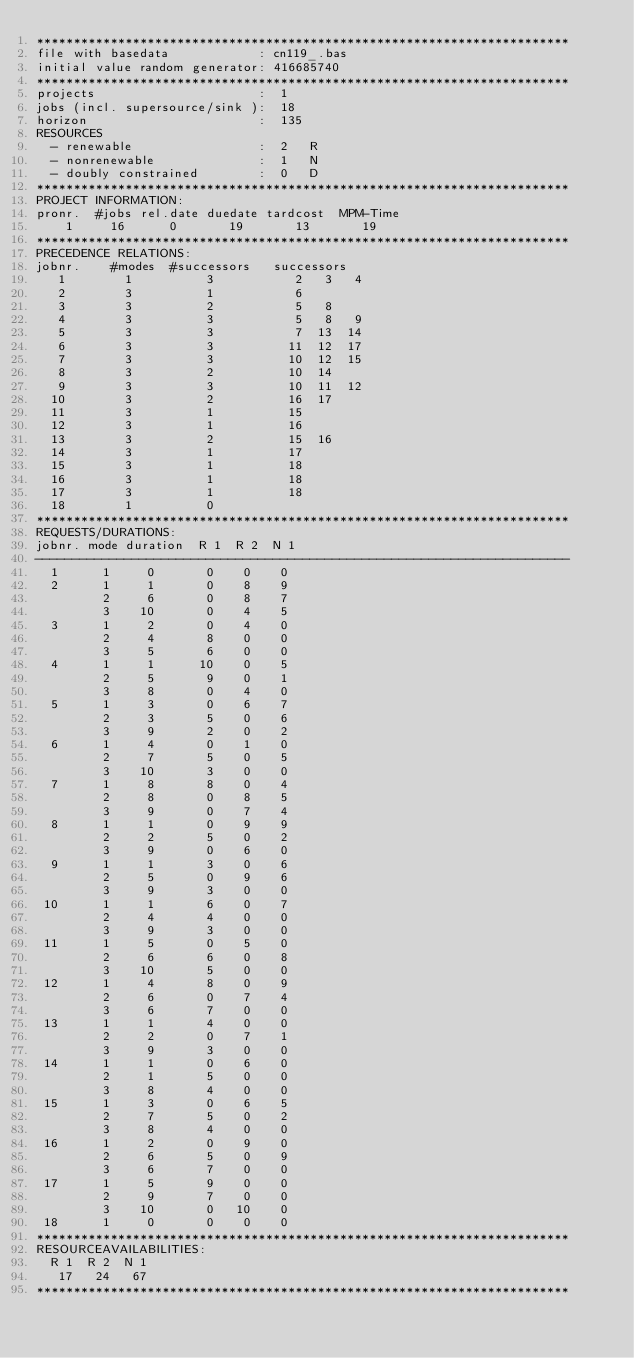Convert code to text. <code><loc_0><loc_0><loc_500><loc_500><_ObjectiveC_>************************************************************************
file with basedata            : cn119_.bas
initial value random generator: 416685740
************************************************************************
projects                      :  1
jobs (incl. supersource/sink ):  18
horizon                       :  135
RESOURCES
  - renewable                 :  2   R
  - nonrenewable              :  1   N
  - doubly constrained        :  0   D
************************************************************************
PROJECT INFORMATION:
pronr.  #jobs rel.date duedate tardcost  MPM-Time
    1     16      0       19       13       19
************************************************************************
PRECEDENCE RELATIONS:
jobnr.    #modes  #successors   successors
   1        1          3           2   3   4
   2        3          1           6
   3        3          2           5   8
   4        3          3           5   8   9
   5        3          3           7  13  14
   6        3          3          11  12  17
   7        3          3          10  12  15
   8        3          2          10  14
   9        3          3          10  11  12
  10        3          2          16  17
  11        3          1          15
  12        3          1          16
  13        3          2          15  16
  14        3          1          17
  15        3          1          18
  16        3          1          18
  17        3          1          18
  18        1          0        
************************************************************************
REQUESTS/DURATIONS:
jobnr. mode duration  R 1  R 2  N 1
------------------------------------------------------------------------
  1      1     0       0    0    0
  2      1     1       0    8    9
         2     6       0    8    7
         3    10       0    4    5
  3      1     2       0    4    0
         2     4       8    0    0
         3     5       6    0    0
  4      1     1      10    0    5
         2     5       9    0    1
         3     8       0    4    0
  5      1     3       0    6    7
         2     3       5    0    6
         3     9       2    0    2
  6      1     4       0    1    0
         2     7       5    0    5
         3    10       3    0    0
  7      1     8       8    0    4
         2     8       0    8    5
         3     9       0    7    4
  8      1     1       0    9    9
         2     2       5    0    2
         3     9       0    6    0
  9      1     1       3    0    6
         2     5       0    9    6
         3     9       3    0    0
 10      1     1       6    0    7
         2     4       4    0    0
         3     9       3    0    0
 11      1     5       0    5    0
         2     6       6    0    8
         3    10       5    0    0
 12      1     4       8    0    9
         2     6       0    7    4
         3     6       7    0    0
 13      1     1       4    0    0
         2     2       0    7    1
         3     9       3    0    0
 14      1     1       0    6    0
         2     1       5    0    0
         3     8       4    0    0
 15      1     3       0    6    5
         2     7       5    0    2
         3     8       4    0    0
 16      1     2       0    9    0
         2     6       5    0    9
         3     6       7    0    0
 17      1     5       9    0    0
         2     9       7    0    0
         3    10       0   10    0
 18      1     0       0    0    0
************************************************************************
RESOURCEAVAILABILITIES:
  R 1  R 2  N 1
   17   24   67
************************************************************************
</code> 